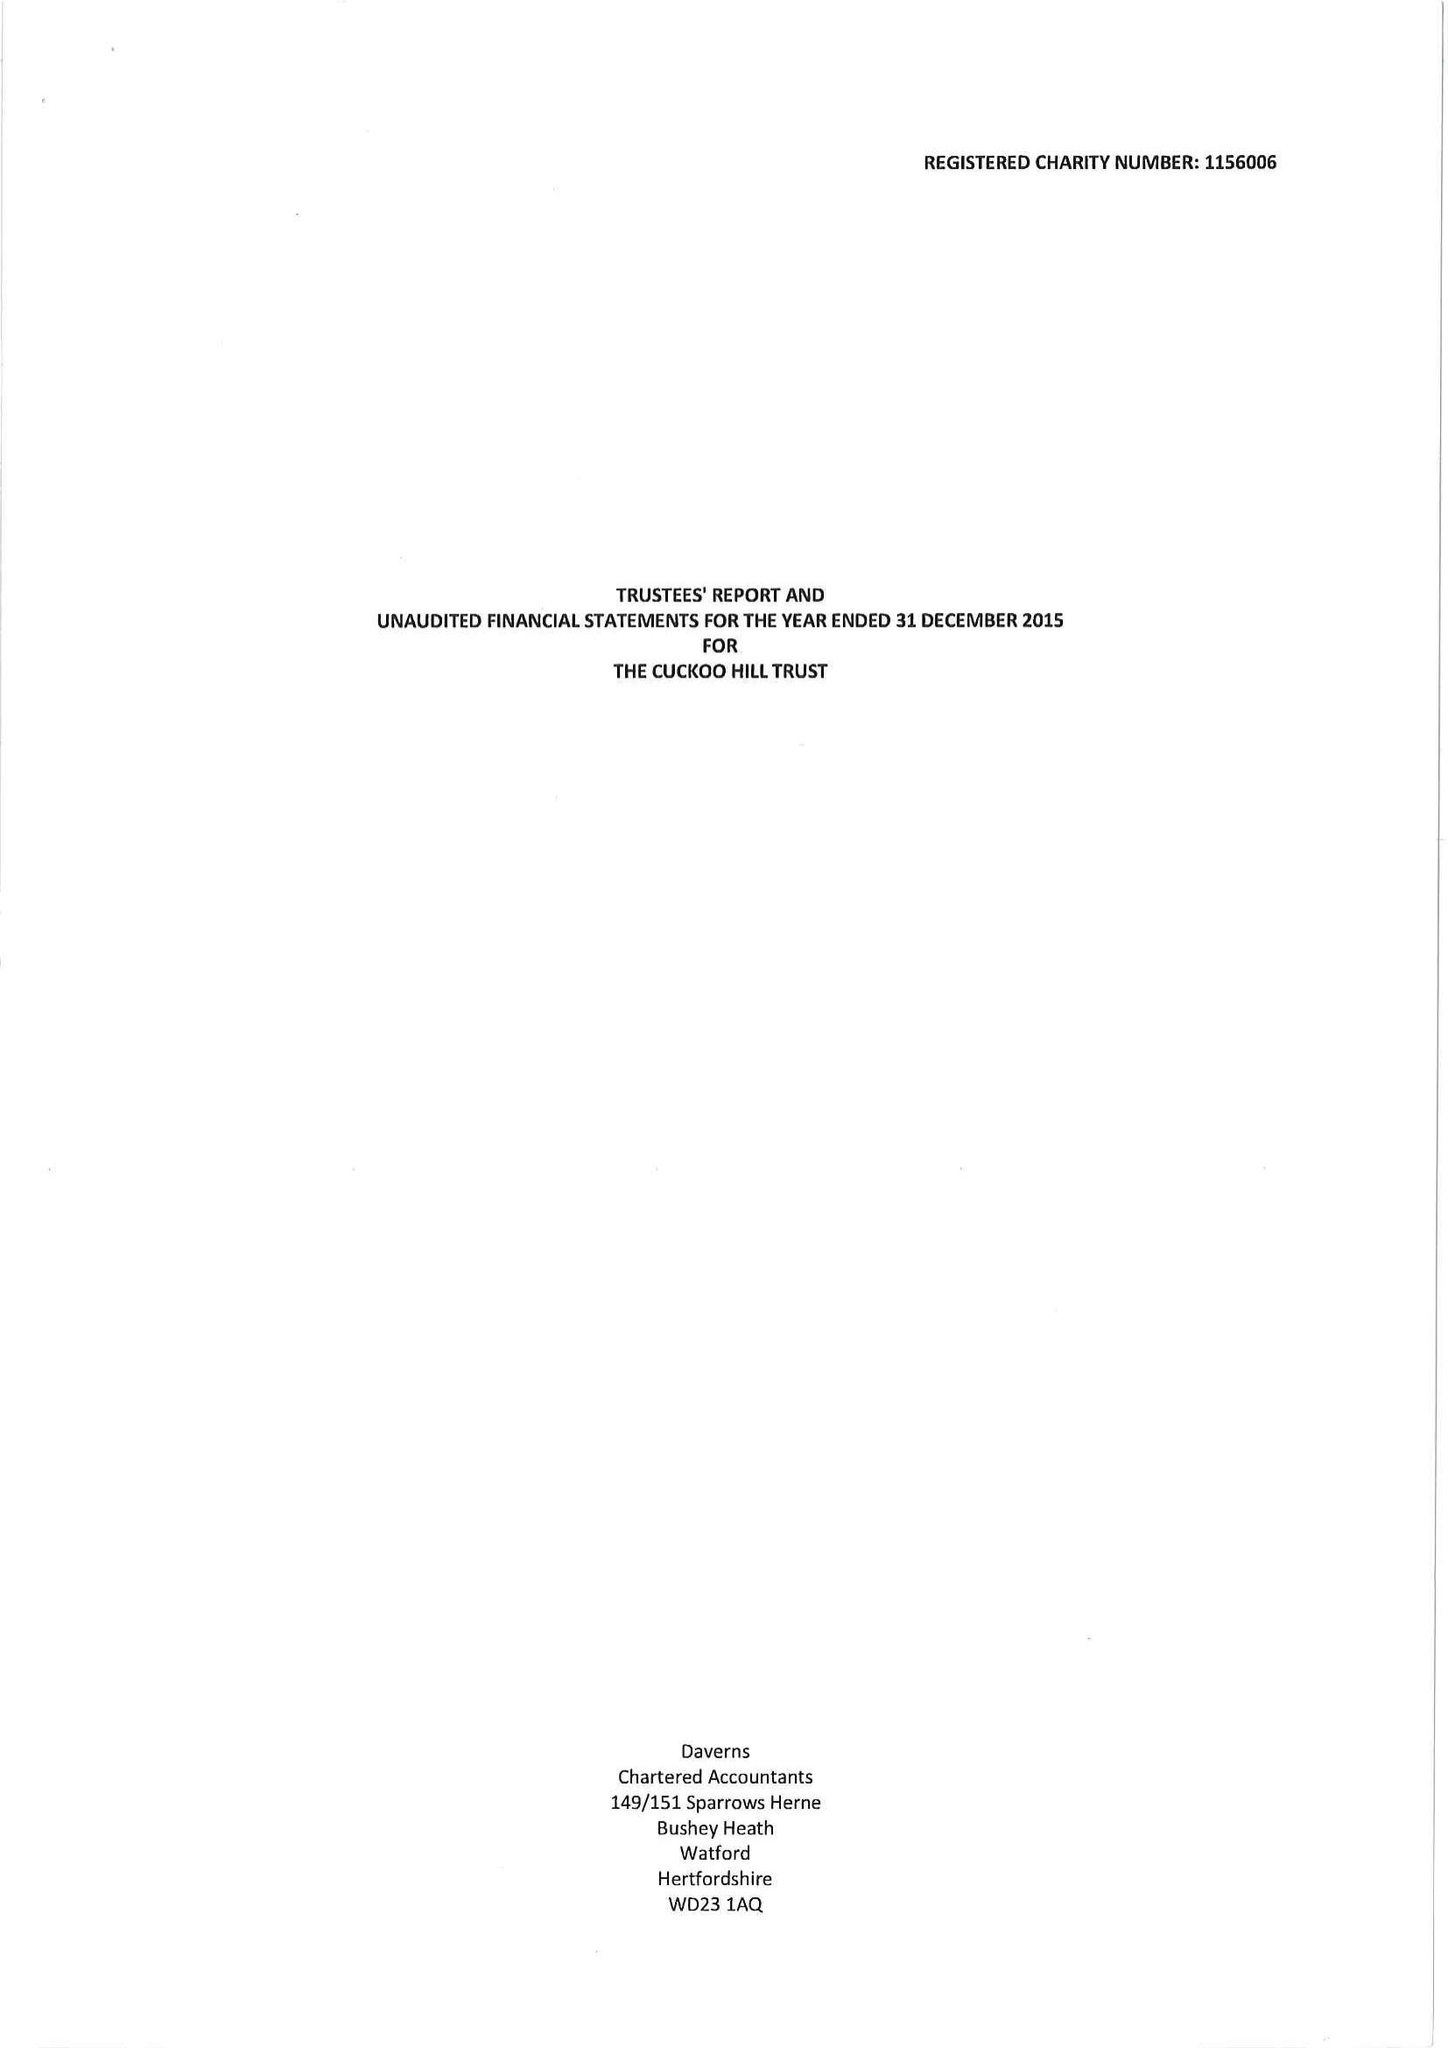What is the value for the report_date?
Answer the question using a single word or phrase. 2015-12-31 